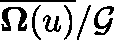<formula> <loc_0><loc_0><loc_500><loc_500>\overline { { \Omega ( \mathfrak { u } ) } } / \mathcal { G }</formula> 